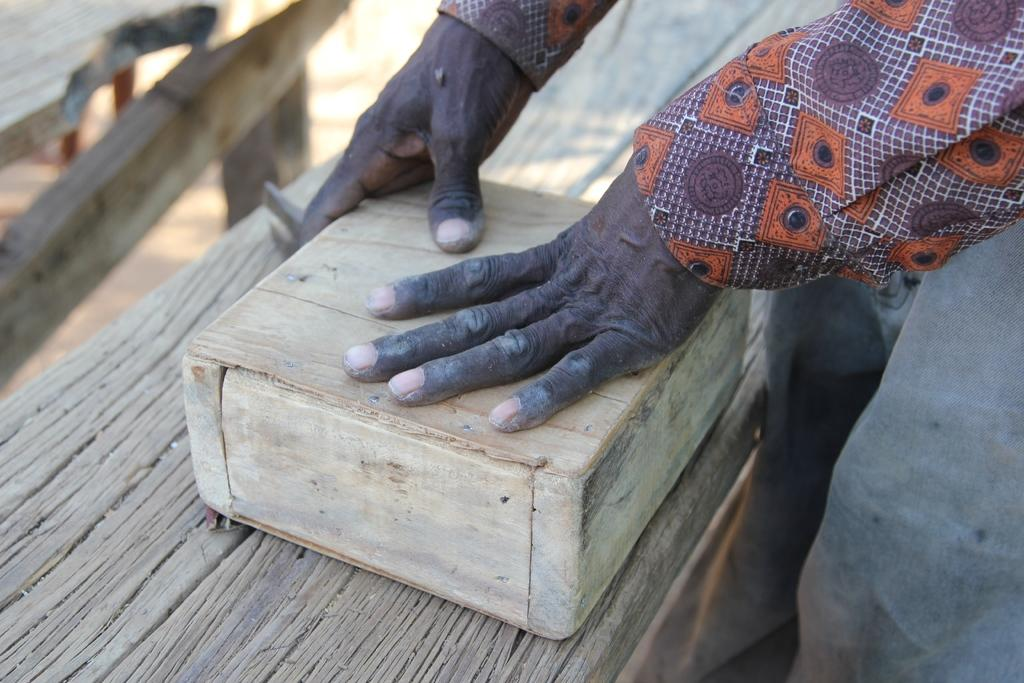What is the main subject of the image? There is a person in the image. What is the person doing with his hands? The person has his hands on a wooden object. Are there any other wooden objects in the image? Yes, there are other wooden objects in the image. What type of footwear is the person wearing in the image? There is no information about the person's footwear in the image. Can you see any windows in the image? There is no mention of windows in the provided facts, so we cannot determine if any are present in the image. 